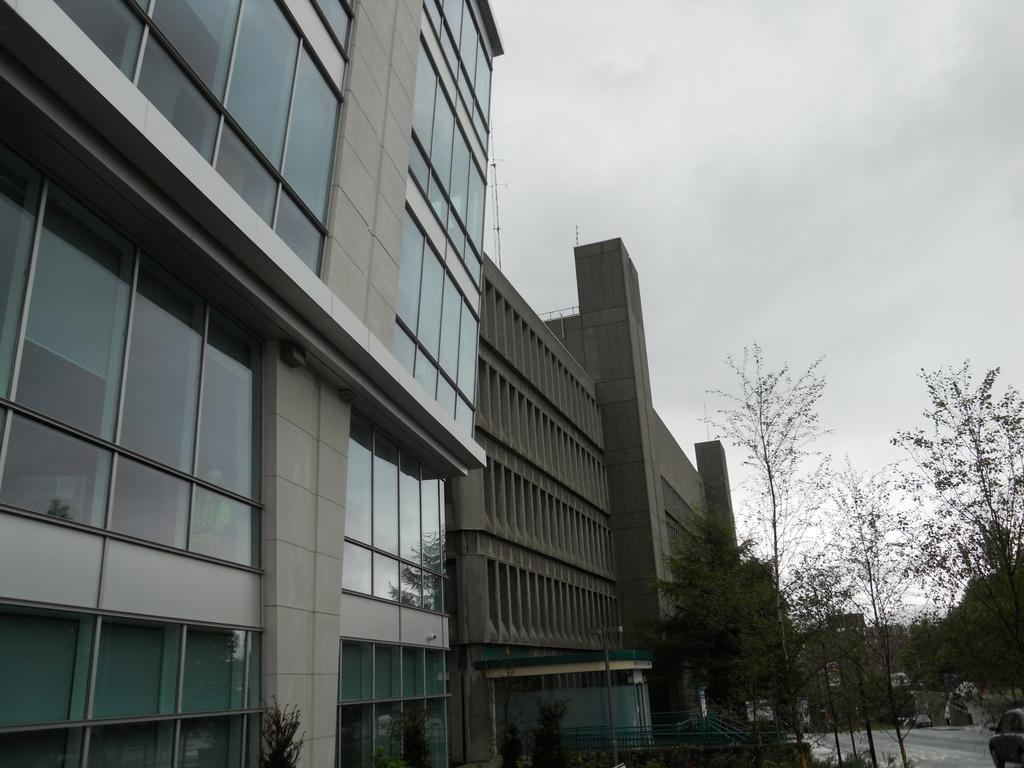What structures are located on the left side of the image? There are buildings on the left side of the image. What type of vegetation is present on the left side of the image? There are trees on the ground on the left side of the image. What type of vegetation is present on the right side of the image? There are trees on the right side of the image. What can be seen on the right side of the image besides trees? There is a road on the right side of the image. What is visible in the background of the image? There are clouds in the sky in the background of the image. What type of ornament is hanging from the trees on the right side of the image? There is no ornament hanging from the trees in the image; only trees and a road are present on the right side. How many balloons can be seen floating in the sky in the image? There are no balloons visible in the image; only clouds are present in the sky. 